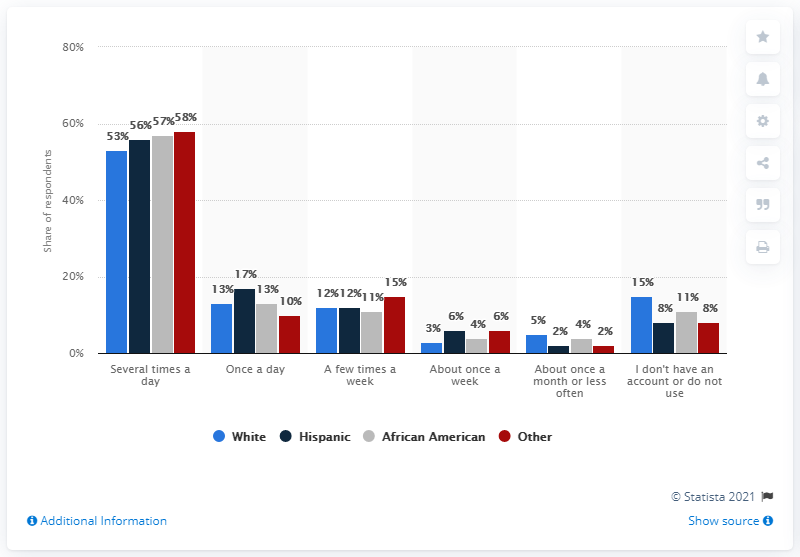Draw attention to some important aspects in this diagram. The ratio between people who consume several times a day and those who consume once a day among Hispanics is 3.294117647.. The missing data in the series "53%, 56%, 58%", is between the value of 57%. 